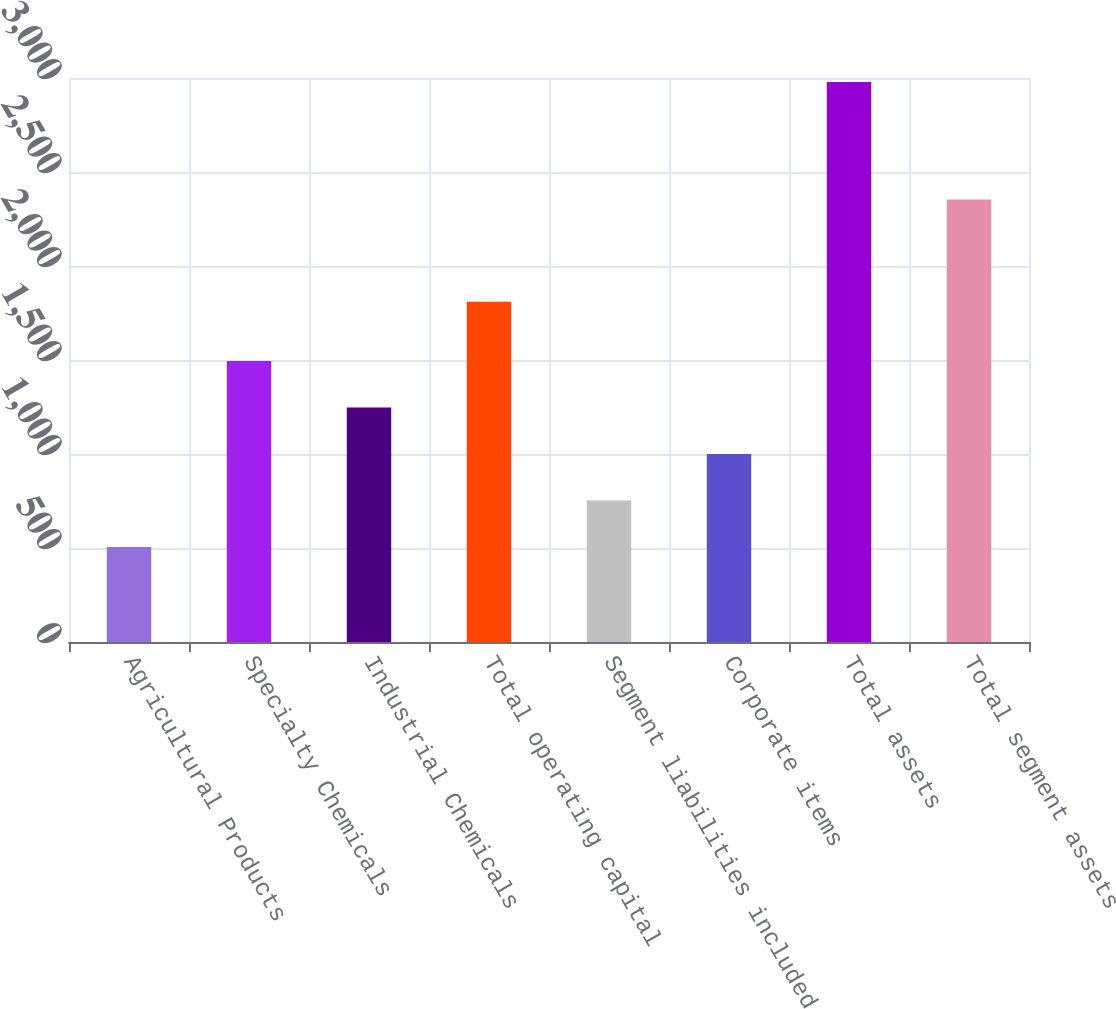Convert chart. <chart><loc_0><loc_0><loc_500><loc_500><bar_chart><fcel>Agricultural Products<fcel>Specialty Chemicals<fcel>Industrial Chemicals<fcel>Total operating capital<fcel>Segment liabilities included<fcel>Corporate items<fcel>Total assets<fcel>Total segment assets<nl><fcel>505<fcel>1494.36<fcel>1247.02<fcel>1809.4<fcel>752.34<fcel>999.68<fcel>2978.4<fcel>2353.1<nl></chart> 